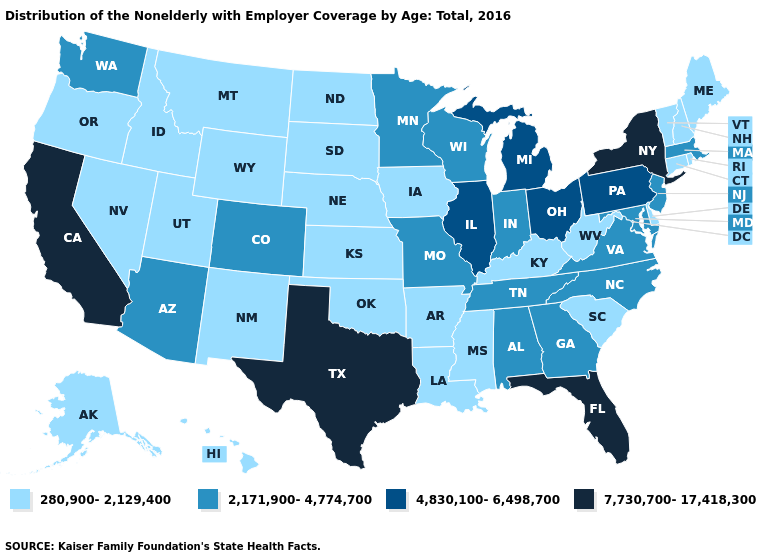Among the states that border Oklahoma , does Texas have the highest value?
Short answer required. Yes. What is the value of Virginia?
Quick response, please. 2,171,900-4,774,700. Name the states that have a value in the range 4,830,100-6,498,700?
Concise answer only. Illinois, Michigan, Ohio, Pennsylvania. What is the value of Utah?
Answer briefly. 280,900-2,129,400. What is the value of Vermont?
Keep it brief. 280,900-2,129,400. What is the value of Washington?
Keep it brief. 2,171,900-4,774,700. What is the value of Connecticut?
Write a very short answer. 280,900-2,129,400. What is the value of Arkansas?
Be succinct. 280,900-2,129,400. Name the states that have a value in the range 280,900-2,129,400?
Give a very brief answer. Alaska, Arkansas, Connecticut, Delaware, Hawaii, Idaho, Iowa, Kansas, Kentucky, Louisiana, Maine, Mississippi, Montana, Nebraska, Nevada, New Hampshire, New Mexico, North Dakota, Oklahoma, Oregon, Rhode Island, South Carolina, South Dakota, Utah, Vermont, West Virginia, Wyoming. What is the value of Alabama?
Write a very short answer. 2,171,900-4,774,700. What is the value of Rhode Island?
Keep it brief. 280,900-2,129,400. What is the highest value in the USA?
Concise answer only. 7,730,700-17,418,300. What is the lowest value in the USA?
Write a very short answer. 280,900-2,129,400. What is the lowest value in the MidWest?
Answer briefly. 280,900-2,129,400. What is the value of Oklahoma?
Short answer required. 280,900-2,129,400. 